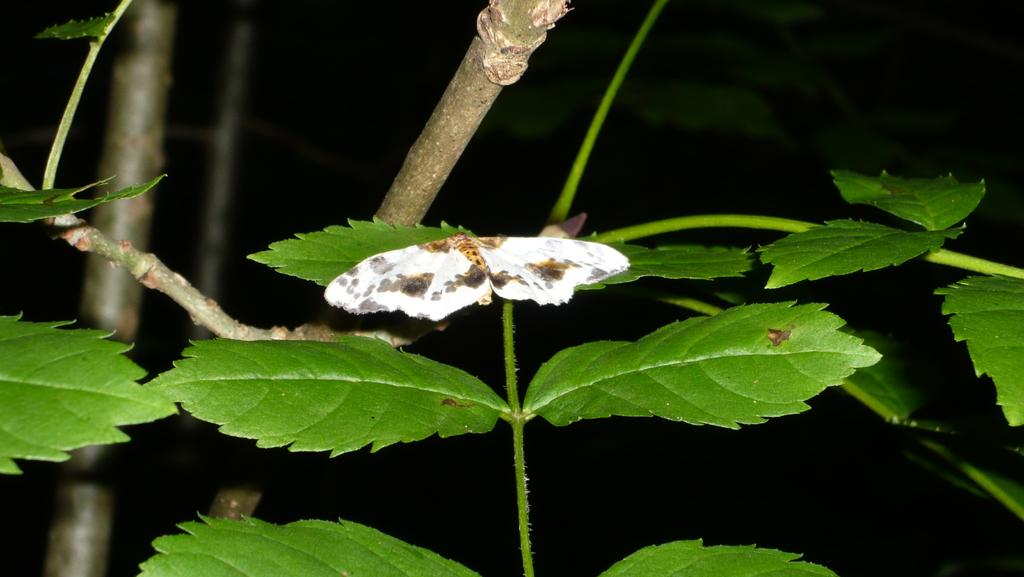What type of vegetation is present in the image? There are leaves in the image. What is the color of the background in the image? The leaves are on a black background. What can be seen in the middle of the image? There is a butterfly in the middle of the image. How many pigs are present in the image? There are no pigs present in the image; it features leaves and a butterfly on a black background. 